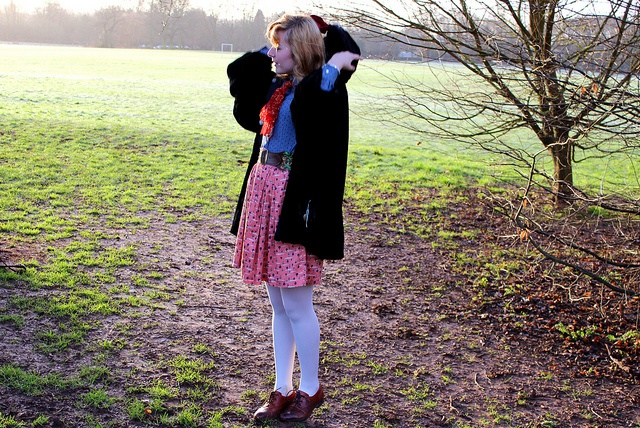Describe the objects in this image and their specific colors. I can see people in white, black, darkgray, violet, and brown tones and tie in white, maroon, brown, salmon, and black tones in this image. 